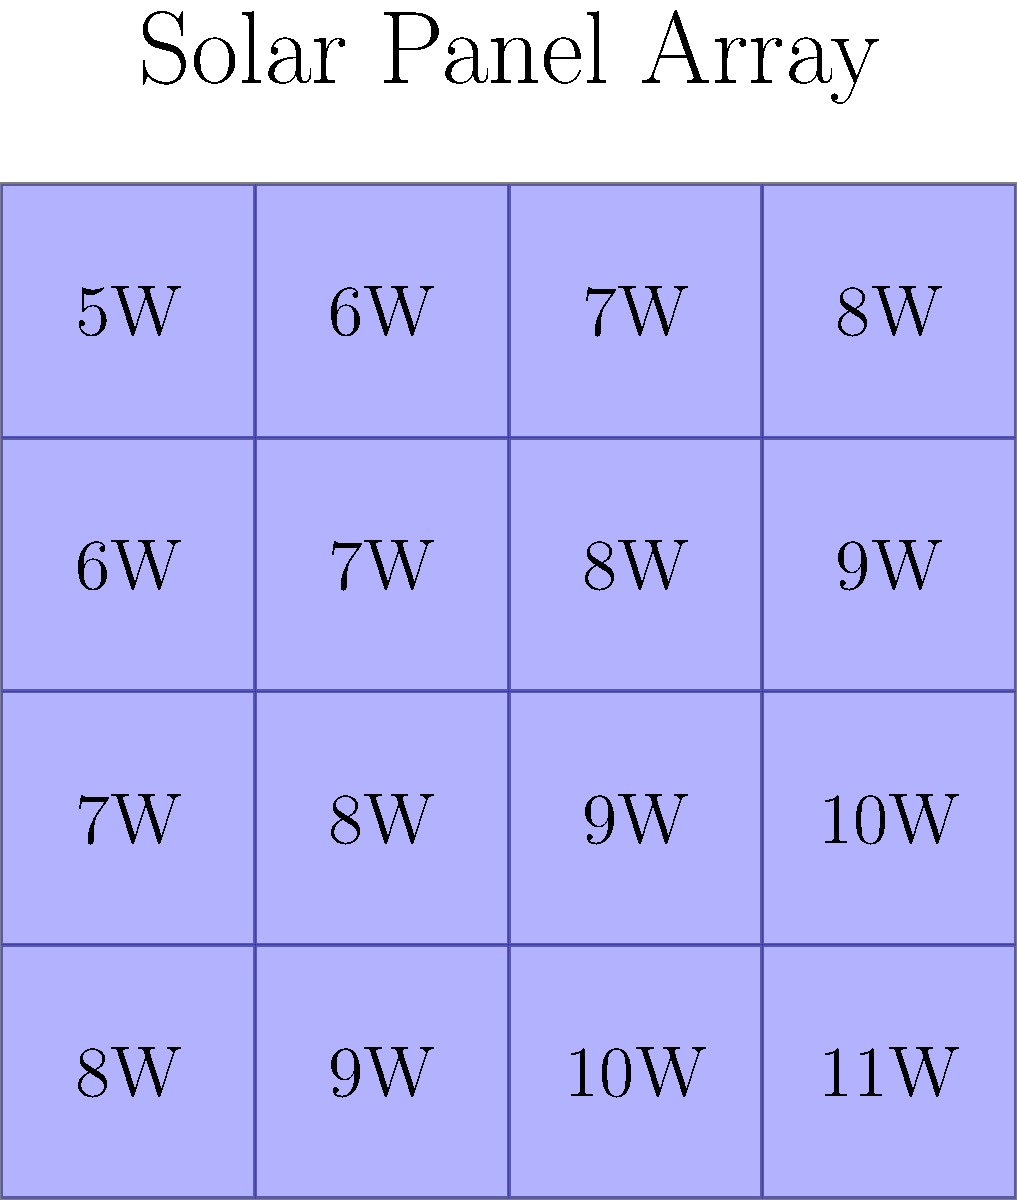A solar panel array is arranged in a 4x4 grid, with each panel's power output (in watts) shown in the diagram. The power output increases by 1W for each step to the right or down. Calculate the total power output of the entire array. To solve this problem, we'll follow these steps:

1) First, let's identify the pattern in the power outputs:
   - The top-left panel produces 5W
   - Each panel to the right increases by 1W
   - Each panel down also increases by 1W

2) We can represent this as a mathematical series:
   $$(5 + 6 + 7 + 8) + (6 + 7 + 8 + 9) + (7 + 8 + 9 + 10) + (8 + 9 + 10 + 11)$$

3) Let's simplify each row:
   $$(26) + (30) + (34) + (38)$$

4) Now, we can sum these values:
   $$26 + 30 + 34 + 38 = 128$$

5) We can verify this by calculating the average power and multiplying by the number of panels:
   - The lowest power is 5W and the highest is 11W
   - Average power = $\frac{5W + 11W}{2} = 8W$
   - Number of panels = 4 × 4 = 16
   - Total power = 8W × 16 = 128W

Therefore, the total power output of the entire array is 128W.
Answer: 128W 